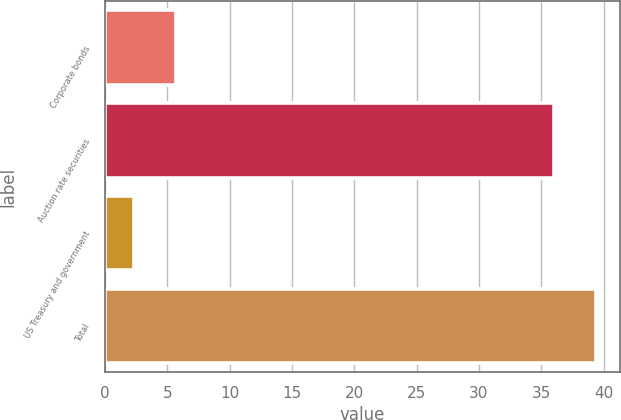Convert chart to OTSL. <chart><loc_0><loc_0><loc_500><loc_500><bar_chart><fcel>Corporate bonds<fcel>Auction rate securities<fcel>US Treasury and government<fcel>Total<nl><fcel>5.7<fcel>36<fcel>2.33<fcel>39.37<nl></chart> 